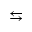Convert formula to latex. <formula><loc_0><loc_0><loc_500><loc_500>\leftrightarrow s</formula> 